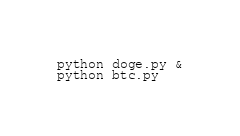Convert code to text. <code><loc_0><loc_0><loc_500><loc_500><_Bash_>python doge.py &
python btc.py</code> 